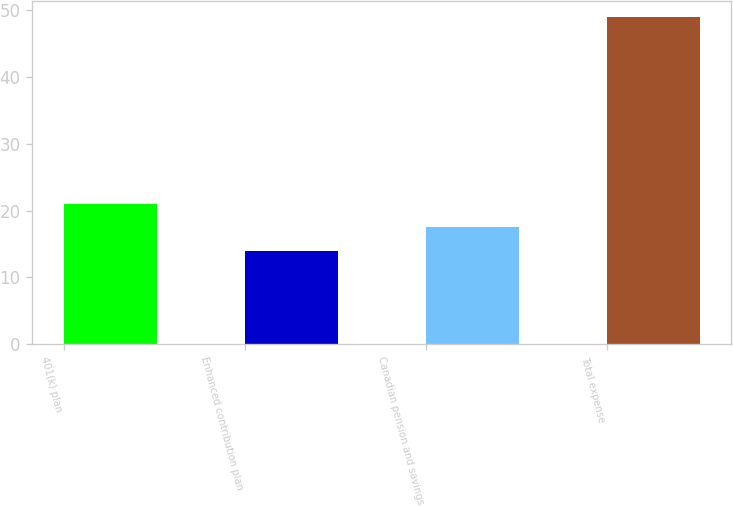Convert chart to OTSL. <chart><loc_0><loc_0><loc_500><loc_500><bar_chart><fcel>401(k) plan<fcel>Enhanced contribution plan<fcel>Canadian pension and savings<fcel>Total expense<nl><fcel>21<fcel>14<fcel>17.5<fcel>49<nl></chart> 